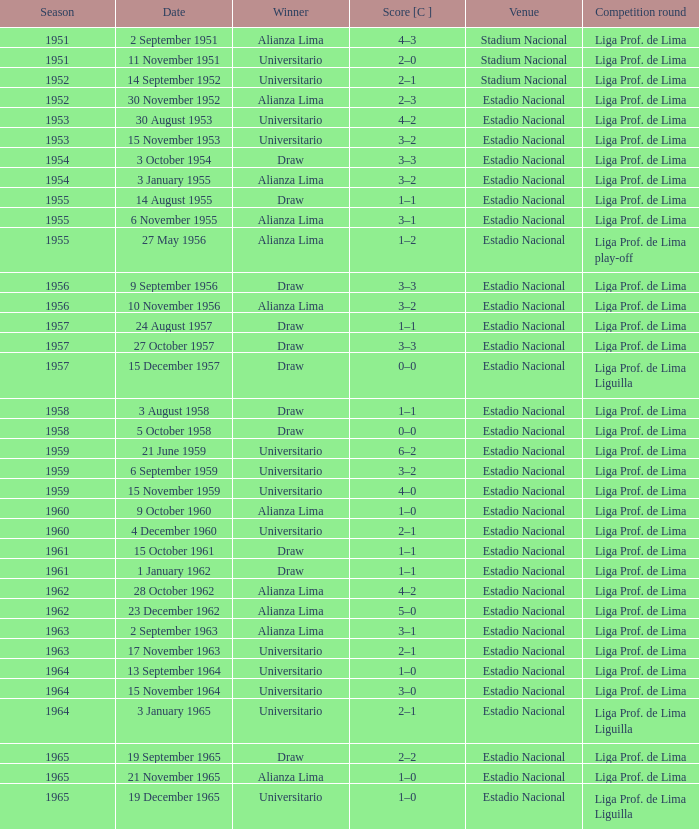What is the score of the event that Alianza Lima won in 1965? 1–0. 